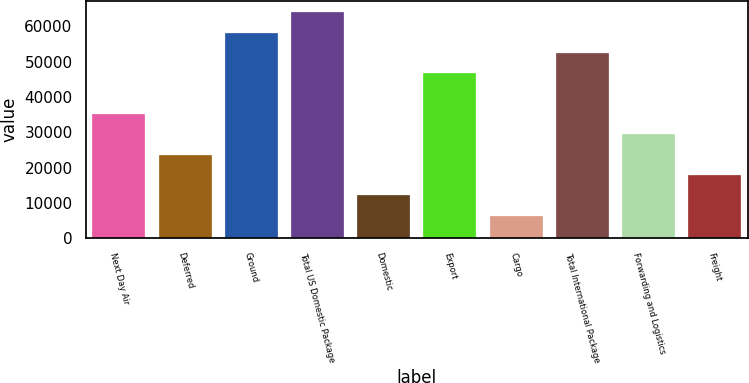Convert chart. <chart><loc_0><loc_0><loc_500><loc_500><bar_chart><fcel>Next Day Air<fcel>Deferred<fcel>Ground<fcel>Total US Domestic Package<fcel>Domestic<fcel>Export<fcel>Cargo<fcel>Total International Package<fcel>Forwarding and Logistics<fcel>Freight<nl><fcel>35174<fcel>23645<fcel>58232<fcel>63996.5<fcel>12116<fcel>46703<fcel>6351.5<fcel>52467.5<fcel>29409.5<fcel>17880.5<nl></chart> 